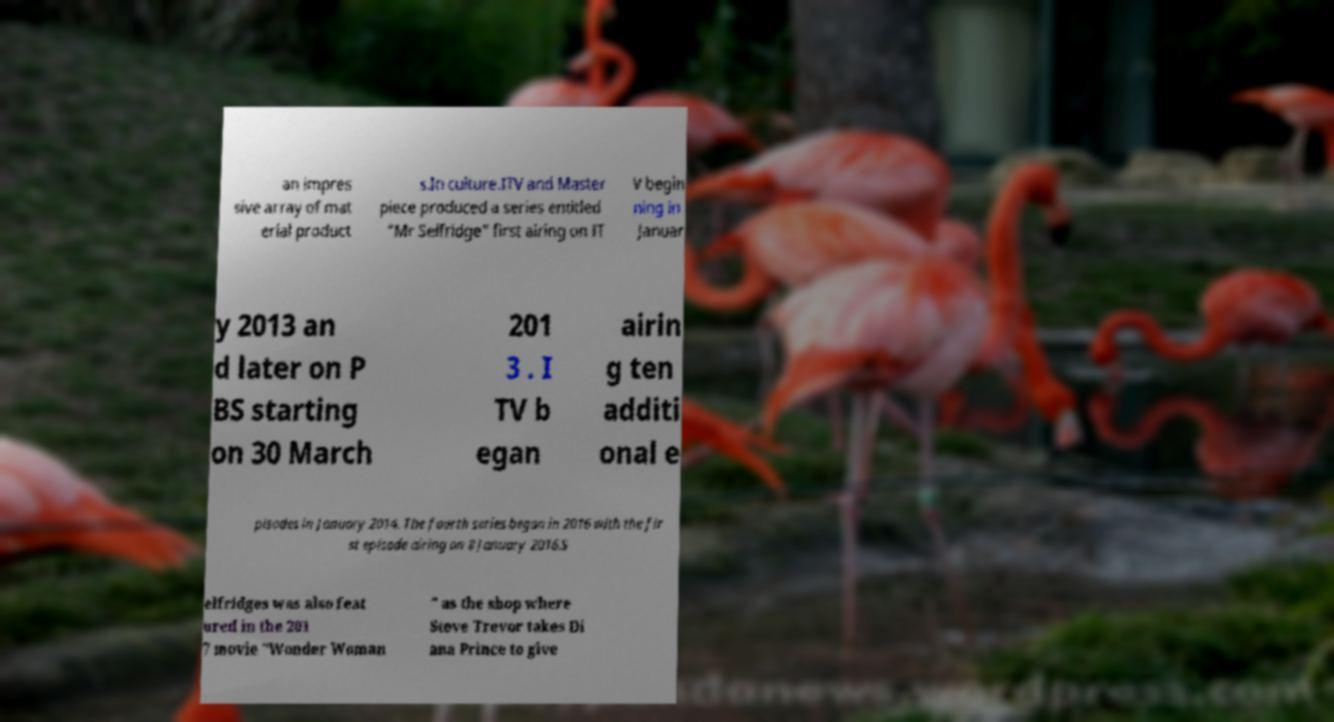For documentation purposes, I need the text within this image transcribed. Could you provide that? an impres sive array of mat erial product s.In culture.ITV and Master piece produced a series entitled "Mr Selfridge" first airing on IT V begin ning in Januar y 2013 an d later on P BS starting on 30 March 201 3 . I TV b egan airin g ten additi onal e pisodes in January 2014. The fourth series began in 2016 with the fir st episode airing on 8 January 2016.S elfridges was also feat ured in the 201 7 movie "Wonder Woman " as the shop where Steve Trevor takes Di ana Prince to give 